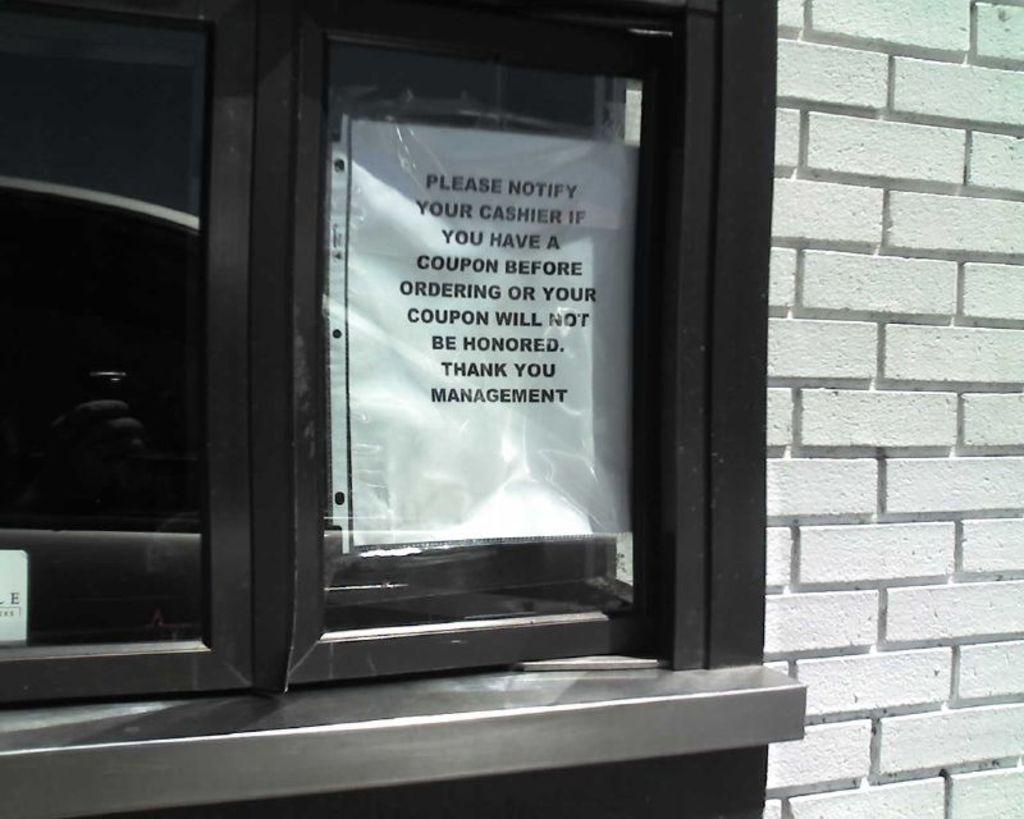<image>
Provide a brief description of the given image. drive up window of a fast food restaurant, with information about coupons 